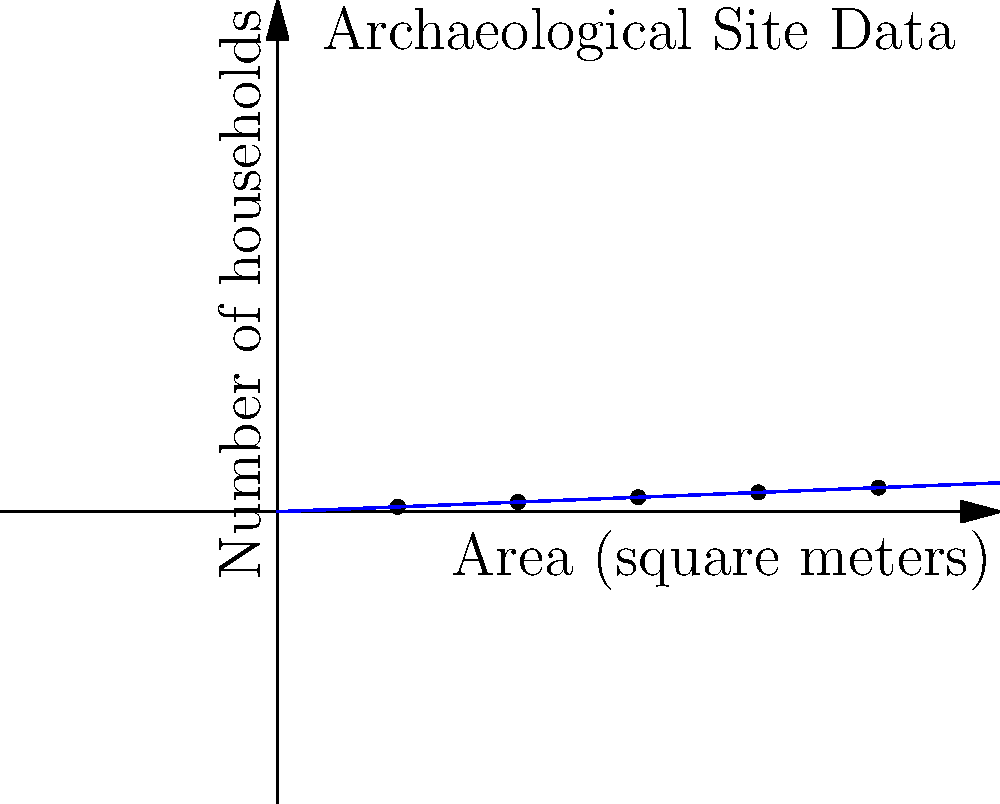Based on the archaeological site layout data shown in the graph, estimate the population density (people per square meter) of this ancient settlement. Assume an average of 5 people per household and that the trend continues linearly beyond the given data points. To solve this problem, we'll follow these steps:

1. Determine the relationship between area and number of households:
   From the graph, we can see that for every 50 square meters, there are 2 additional households.

2. Express this as a mathematical function:
   Let $y$ be the number of households and $x$ be the area in square meters.
   $y = \frac{2}{50}x = 0.04x$

3. Calculate people per household:
   We're given that there are 5 people per household on average.

4. Express population as a function of area:
   Population $= 5y = 5(0.04x) = 0.2x$

5. Calculate population density:
   Density $= \frac{\text{Population}}{\text{Area}} = \frac{0.2x}{x} = 0.2$

Therefore, the population density is 0.2 people per square meter.
Answer: 0.2 people/m² 